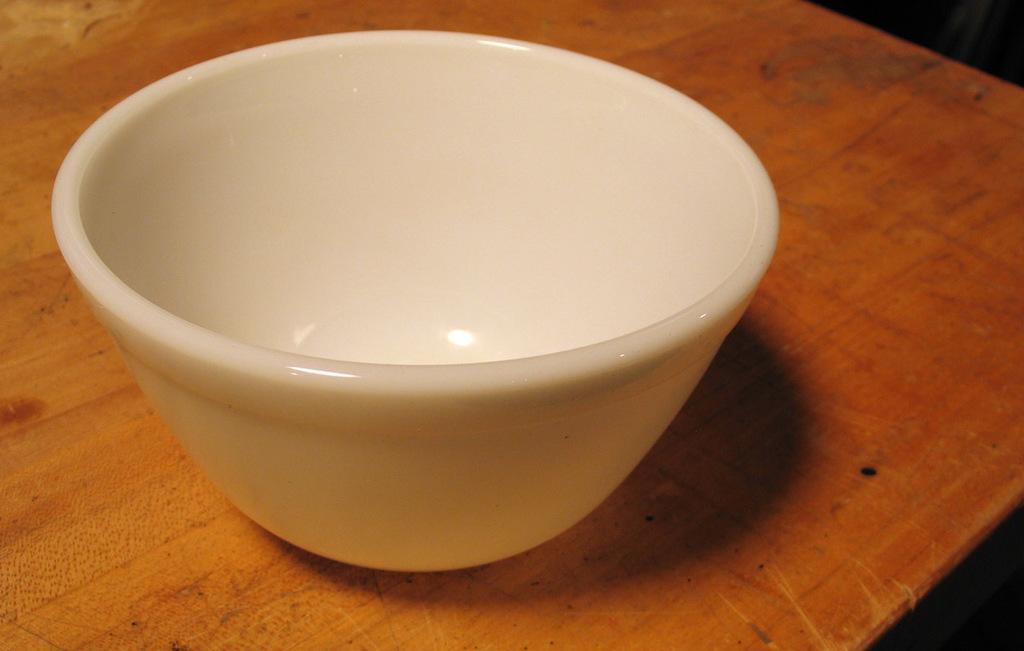Can you describe this image briefly? This image is taken indoors. At the bottom of the image there is a table with a bowl on it. 